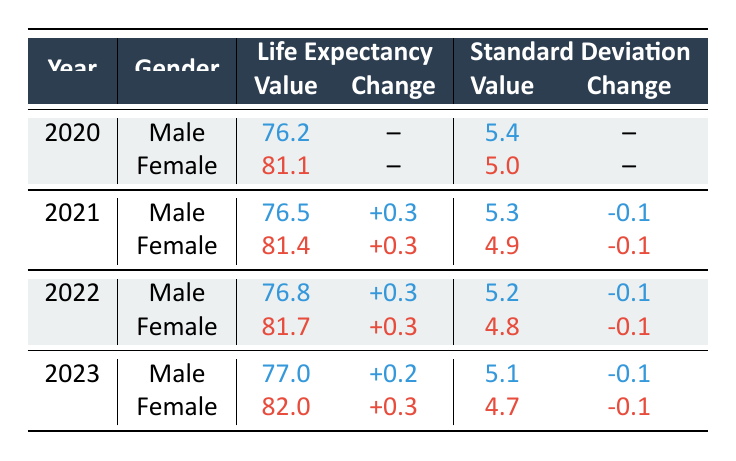What is the life expectancy at birth for males in 2023? From the table, under the year 2023, the life expectancy at birth for males is listed as 77.0.
Answer: 77.0 What is the change in life expectancy for females from 2020 to 2023? In 2020, the life expectancy for females was 81.1, and in 2023, it is 82.0. The change is 82.0 - 81.1 = 0.9.
Answer: 0.9 Is the standard deviation for male life expectancy in 2021 greater than in 2022? The standard deviation for males in 2021 is 5.3 and in 2022 it is 5.2. Since 5.3 > 5.2, the statement is true.
Answer: Yes How much did the life expectancy for females increase from 2021 to 2023? For females in 2021, the life expectancy was 81.4, and in 2023 it is 82.0. The increase is 82.0 - 81.4 = 0.6.
Answer: 0.6 What is the average life expectancy for males over the four years? The life expectancies for males from 2020 to 2023 are 76.2, 76.5, 76.8, and 77.0. To find the average, sum them: 76.2 + 76.5 + 76.8 + 77.0 = 306.5. There are 4 data points, so the average is 306.5 / 4 = 76.625.
Answer: 76.625 What was the standard deviation for female life expectancy in 2022? From the table, the standard deviation for females in 2022 is given as 4.8.
Answer: 4.8 Has the life expectancy for males increased every year from 2020 to 2023? The life expectancy values for males are 76.2, 76.5, 76.8, and 77.0, demonstrating that the life expectancy increased in every subsequent year. Therefore, this statement is true.
Answer: Yes What is the difference in life expectancy between males and females in 2022? In 2022, the life expectancy for males is 76.8 and for females is 81.7. The difference is 81.7 - 76.8 = 4.9.
Answer: 4.9 